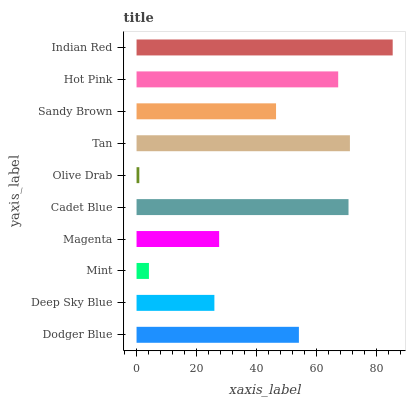Is Olive Drab the minimum?
Answer yes or no. Yes. Is Indian Red the maximum?
Answer yes or no. Yes. Is Deep Sky Blue the minimum?
Answer yes or no. No. Is Deep Sky Blue the maximum?
Answer yes or no. No. Is Dodger Blue greater than Deep Sky Blue?
Answer yes or no. Yes. Is Deep Sky Blue less than Dodger Blue?
Answer yes or no. Yes. Is Deep Sky Blue greater than Dodger Blue?
Answer yes or no. No. Is Dodger Blue less than Deep Sky Blue?
Answer yes or no. No. Is Dodger Blue the high median?
Answer yes or no. Yes. Is Sandy Brown the low median?
Answer yes or no. Yes. Is Tan the high median?
Answer yes or no. No. Is Magenta the low median?
Answer yes or no. No. 